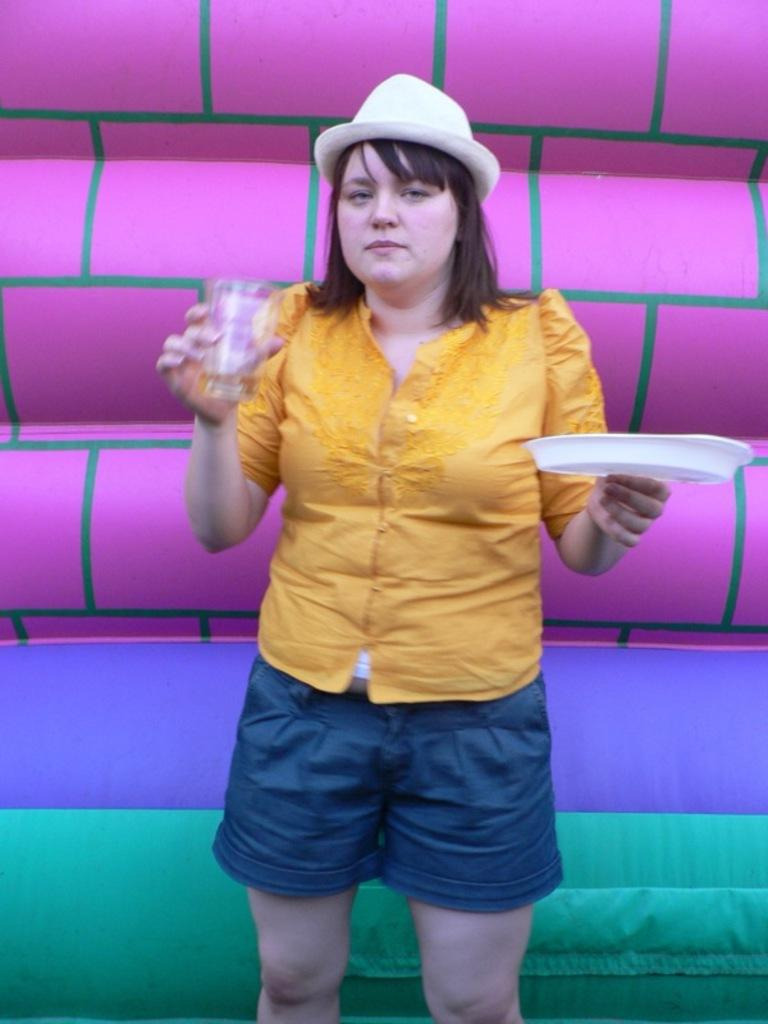What is the main subject of the picture? The main subject of the picture is a girl. What is the girl doing in the picture? The girl is standing in the picture. What objects is the girl holding? The girl is holding a plate and a glass. What can be seen in the background of the picture? There is a balloon visible in the background of the picture. What type of crack is visible on the girl's plate in the image? There is no crack visible on the girl's plate in the image. What is the condition of the pail in the image? There is no pail present in the image. 